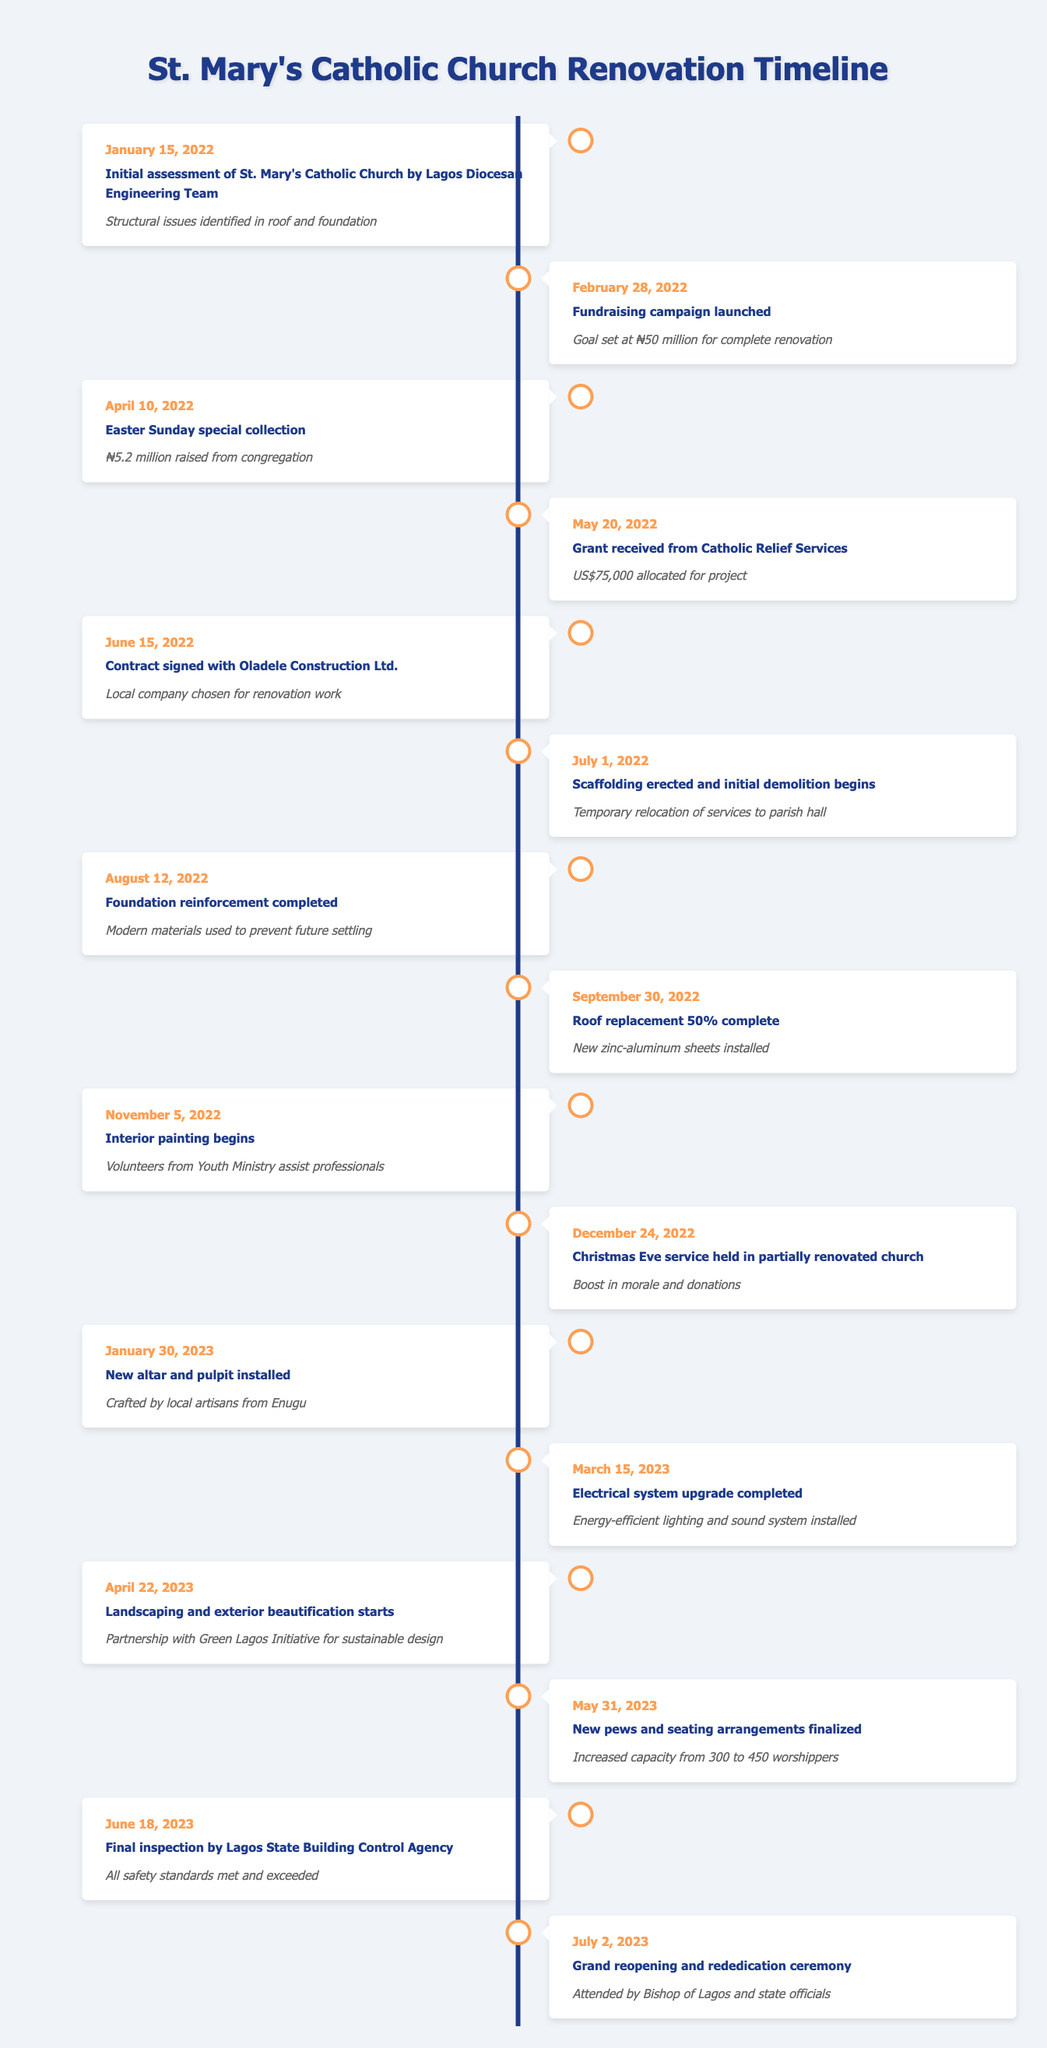What date was the initial assessment of St. Mary's Catholic Church? The initial assessment took place on January 15, 2022, as noted in the first entry of the table.
Answer: January 15, 2022 How much was raised during the Easter Sunday special collection? The table states that ₦5.2 million was raised from the congregation during the Easter Sunday special collection on April 10, 2022.
Answer: ₦5.2 million Was the contract signed with a local construction company? Yes, the contract was signed with Oladele Construction Ltd., which is indicated as a local company chosen for the renovation work.
Answer: Yes What percentage of the roof replacement was completed on September 30, 2022? The table shows that the roof replacement was 50% complete as of September 30, 2022.
Answer: 50% What was the total amount raised by the end of the fundraising campaign? To determine this, we need to sum the amounts from the Easter collection and the grant, which totals ₦5.2 million (Easter collection) + US$75,000 (approximately ₦31 million, assuming an exchange rate of ₦415 to US$1); thus, 5.2 + 31 = ₦36.2 million raised.
Answer: ₦36.2 million How many months passed from the start of the project on January 15, 2022, to the grand reopening on July 2, 2023? The project started on January 15, 2022, and ended with the grand reopening on July 2, 2023, which is 18 months from start to finish.
Answer: 18 months What significant milestone occurred on March 15, 2023? According to the table, on March 15, 2023, the electrical system upgrade was completed, which included the installation of energy-efficient lighting and a sound system.
Answer: Electrical system upgrade completed Was there a service held in the church before the renovations were finished? Yes, a Christmas Eve service was held in the partially renovated church on December 24, 2022, which is a clear indication that some work was completed at that time.
Answer: Yes 